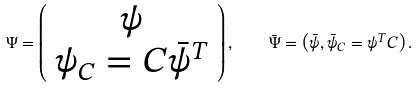<formula> <loc_0><loc_0><loc_500><loc_500>\Psi = \left ( \begin{array} { c } \psi \\ \psi _ { C } = C \bar { \psi } ^ { T } \end{array} \right ) , \quad & \bar { \Psi } = \left ( \bar { \psi } , \bar { \psi } _ { C } = \psi ^ { T } C \right ) .</formula> 